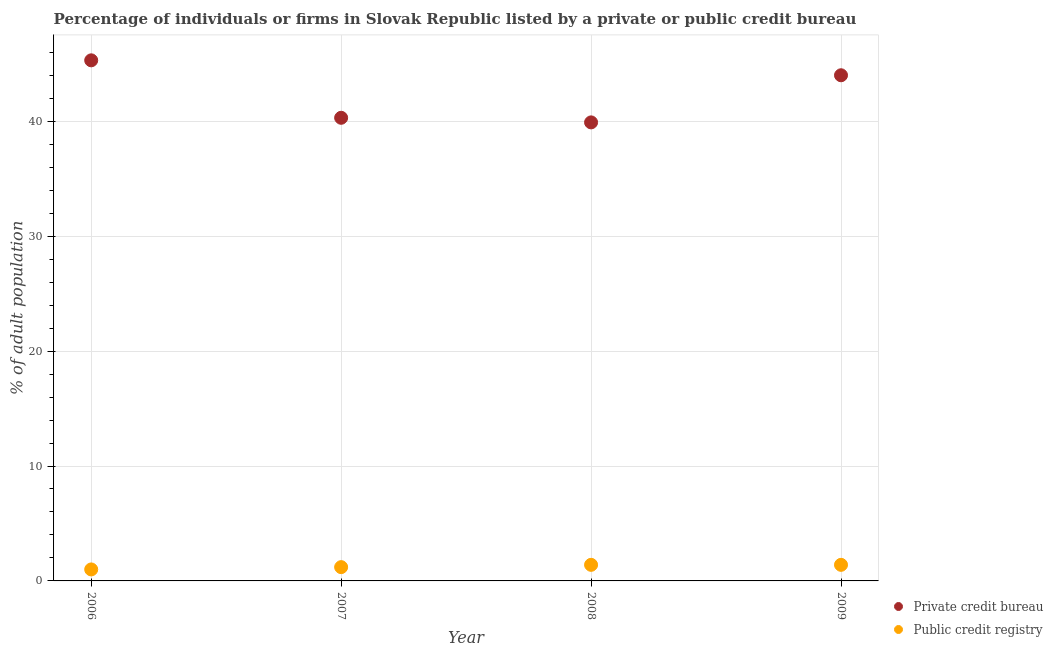How many different coloured dotlines are there?
Make the answer very short. 2. Is the number of dotlines equal to the number of legend labels?
Make the answer very short. Yes. What is the percentage of firms listed by private credit bureau in 2006?
Give a very brief answer. 45.3. Across all years, what is the maximum percentage of firms listed by private credit bureau?
Keep it short and to the point. 45.3. Across all years, what is the minimum percentage of firms listed by private credit bureau?
Offer a terse response. 39.9. What is the total percentage of firms listed by private credit bureau in the graph?
Provide a succinct answer. 169.5. What is the difference between the percentage of firms listed by private credit bureau in 2006 and that in 2008?
Your response must be concise. 5.4. What is the difference between the percentage of firms listed by public credit bureau in 2006 and the percentage of firms listed by private credit bureau in 2009?
Ensure brevity in your answer.  -43. What is the average percentage of firms listed by public credit bureau per year?
Keep it short and to the point. 1.25. In the year 2008, what is the difference between the percentage of firms listed by public credit bureau and percentage of firms listed by private credit bureau?
Offer a very short reply. -38.5. In how many years, is the percentage of firms listed by private credit bureau greater than 8 %?
Ensure brevity in your answer.  4. What is the ratio of the percentage of firms listed by private credit bureau in 2006 to that in 2007?
Keep it short and to the point. 1.12. Is the difference between the percentage of firms listed by public credit bureau in 2006 and 2007 greater than the difference between the percentage of firms listed by private credit bureau in 2006 and 2007?
Provide a short and direct response. No. What is the difference between the highest and the second highest percentage of firms listed by private credit bureau?
Your answer should be compact. 1.3. What is the difference between the highest and the lowest percentage of firms listed by public credit bureau?
Provide a succinct answer. 0.4. In how many years, is the percentage of firms listed by public credit bureau greater than the average percentage of firms listed by public credit bureau taken over all years?
Provide a short and direct response. 2. Is the percentage of firms listed by public credit bureau strictly greater than the percentage of firms listed by private credit bureau over the years?
Provide a succinct answer. No. How many dotlines are there?
Give a very brief answer. 2. How many years are there in the graph?
Your answer should be very brief. 4. Are the values on the major ticks of Y-axis written in scientific E-notation?
Give a very brief answer. No. Does the graph contain any zero values?
Provide a short and direct response. No. Does the graph contain grids?
Your response must be concise. Yes. Where does the legend appear in the graph?
Keep it short and to the point. Bottom right. How are the legend labels stacked?
Provide a succinct answer. Vertical. What is the title of the graph?
Keep it short and to the point. Percentage of individuals or firms in Slovak Republic listed by a private or public credit bureau. What is the label or title of the X-axis?
Your response must be concise. Year. What is the label or title of the Y-axis?
Provide a succinct answer. % of adult population. What is the % of adult population in Private credit bureau in 2006?
Your answer should be very brief. 45.3. What is the % of adult population of Public credit registry in 2006?
Offer a very short reply. 1. What is the % of adult population of Private credit bureau in 2007?
Your response must be concise. 40.3. What is the % of adult population in Public credit registry in 2007?
Keep it short and to the point. 1.2. What is the % of adult population in Private credit bureau in 2008?
Provide a succinct answer. 39.9. What is the % of adult population of Private credit bureau in 2009?
Your response must be concise. 44. What is the % of adult population of Public credit registry in 2009?
Offer a very short reply. 1.4. Across all years, what is the maximum % of adult population of Private credit bureau?
Your answer should be very brief. 45.3. Across all years, what is the maximum % of adult population in Public credit registry?
Your response must be concise. 1.4. Across all years, what is the minimum % of adult population in Private credit bureau?
Offer a terse response. 39.9. Across all years, what is the minimum % of adult population in Public credit registry?
Your response must be concise. 1. What is the total % of adult population of Private credit bureau in the graph?
Your response must be concise. 169.5. What is the total % of adult population of Public credit registry in the graph?
Make the answer very short. 5. What is the difference between the % of adult population in Private credit bureau in 2006 and that in 2009?
Provide a short and direct response. 1.3. What is the difference between the % of adult population of Public credit registry in 2006 and that in 2009?
Your answer should be compact. -0.4. What is the difference between the % of adult population of Private credit bureau in 2007 and that in 2009?
Your answer should be compact. -3.7. What is the difference between the % of adult population in Public credit registry in 2007 and that in 2009?
Make the answer very short. -0.2. What is the difference between the % of adult population of Private credit bureau in 2008 and that in 2009?
Your response must be concise. -4.1. What is the difference between the % of adult population of Public credit registry in 2008 and that in 2009?
Offer a terse response. 0. What is the difference between the % of adult population in Private credit bureau in 2006 and the % of adult population in Public credit registry in 2007?
Offer a terse response. 44.1. What is the difference between the % of adult population of Private credit bureau in 2006 and the % of adult population of Public credit registry in 2008?
Provide a short and direct response. 43.9. What is the difference between the % of adult population of Private credit bureau in 2006 and the % of adult population of Public credit registry in 2009?
Ensure brevity in your answer.  43.9. What is the difference between the % of adult population in Private credit bureau in 2007 and the % of adult population in Public credit registry in 2008?
Your answer should be very brief. 38.9. What is the difference between the % of adult population of Private credit bureau in 2007 and the % of adult population of Public credit registry in 2009?
Offer a terse response. 38.9. What is the difference between the % of adult population of Private credit bureau in 2008 and the % of adult population of Public credit registry in 2009?
Your response must be concise. 38.5. What is the average % of adult population of Private credit bureau per year?
Keep it short and to the point. 42.38. What is the average % of adult population in Public credit registry per year?
Your answer should be very brief. 1.25. In the year 2006, what is the difference between the % of adult population of Private credit bureau and % of adult population of Public credit registry?
Provide a short and direct response. 44.3. In the year 2007, what is the difference between the % of adult population of Private credit bureau and % of adult population of Public credit registry?
Keep it short and to the point. 39.1. In the year 2008, what is the difference between the % of adult population in Private credit bureau and % of adult population in Public credit registry?
Offer a terse response. 38.5. In the year 2009, what is the difference between the % of adult population of Private credit bureau and % of adult population of Public credit registry?
Provide a short and direct response. 42.6. What is the ratio of the % of adult population in Private credit bureau in 2006 to that in 2007?
Provide a short and direct response. 1.12. What is the ratio of the % of adult population in Public credit registry in 2006 to that in 2007?
Offer a terse response. 0.83. What is the ratio of the % of adult population in Private credit bureau in 2006 to that in 2008?
Your answer should be compact. 1.14. What is the ratio of the % of adult population in Public credit registry in 2006 to that in 2008?
Provide a short and direct response. 0.71. What is the ratio of the % of adult population of Private credit bureau in 2006 to that in 2009?
Provide a succinct answer. 1.03. What is the ratio of the % of adult population of Private credit bureau in 2007 to that in 2009?
Give a very brief answer. 0.92. What is the ratio of the % of adult population in Public credit registry in 2007 to that in 2009?
Provide a succinct answer. 0.86. What is the ratio of the % of adult population of Private credit bureau in 2008 to that in 2009?
Your answer should be very brief. 0.91. What is the difference between the highest and the second highest % of adult population in Public credit registry?
Make the answer very short. 0. What is the difference between the highest and the lowest % of adult population in Private credit bureau?
Keep it short and to the point. 5.4. What is the difference between the highest and the lowest % of adult population of Public credit registry?
Provide a succinct answer. 0.4. 